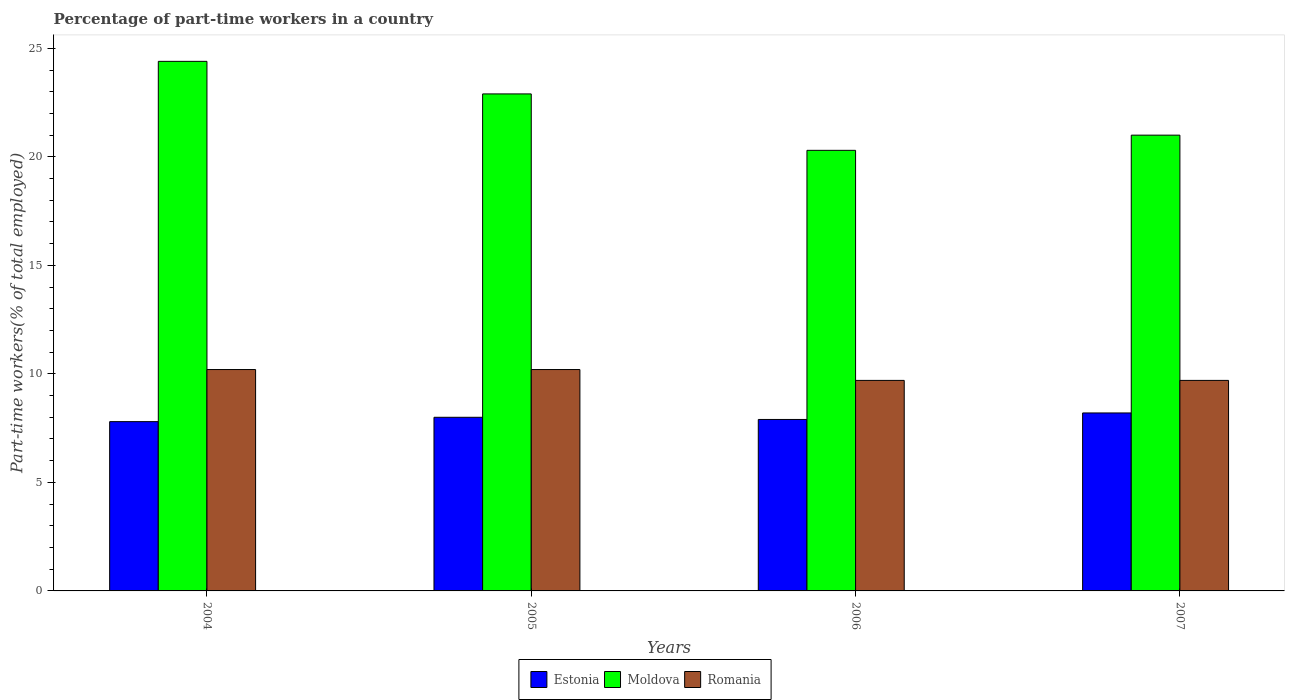How many different coloured bars are there?
Offer a terse response. 3. Are the number of bars on each tick of the X-axis equal?
Ensure brevity in your answer.  Yes. How many bars are there on the 1st tick from the left?
Offer a terse response. 3. How many bars are there on the 4th tick from the right?
Make the answer very short. 3. In how many cases, is the number of bars for a given year not equal to the number of legend labels?
Keep it short and to the point. 0. What is the percentage of part-time workers in Estonia in 2004?
Give a very brief answer. 7.8. Across all years, what is the maximum percentage of part-time workers in Estonia?
Ensure brevity in your answer.  8.2. Across all years, what is the minimum percentage of part-time workers in Moldova?
Give a very brief answer. 20.3. In which year was the percentage of part-time workers in Estonia maximum?
Offer a terse response. 2007. What is the total percentage of part-time workers in Estonia in the graph?
Keep it short and to the point. 31.9. What is the difference between the percentage of part-time workers in Romania in 2004 and that in 2007?
Give a very brief answer. 0.5. What is the difference between the percentage of part-time workers in Romania in 2007 and the percentage of part-time workers in Moldova in 2005?
Keep it short and to the point. -13.2. What is the average percentage of part-time workers in Romania per year?
Offer a terse response. 9.95. In the year 2005, what is the difference between the percentage of part-time workers in Estonia and percentage of part-time workers in Moldova?
Offer a very short reply. -14.9. What is the ratio of the percentage of part-time workers in Estonia in 2005 to that in 2007?
Keep it short and to the point. 0.98. Is the percentage of part-time workers in Romania in 2004 less than that in 2007?
Keep it short and to the point. No. Is the difference between the percentage of part-time workers in Estonia in 2006 and 2007 greater than the difference between the percentage of part-time workers in Moldova in 2006 and 2007?
Provide a short and direct response. Yes. What is the difference between the highest and the second highest percentage of part-time workers in Estonia?
Ensure brevity in your answer.  0.2. What is the difference between the highest and the lowest percentage of part-time workers in Estonia?
Offer a very short reply. 0.4. In how many years, is the percentage of part-time workers in Moldova greater than the average percentage of part-time workers in Moldova taken over all years?
Offer a terse response. 2. Is the sum of the percentage of part-time workers in Estonia in 2006 and 2007 greater than the maximum percentage of part-time workers in Romania across all years?
Ensure brevity in your answer.  Yes. What does the 3rd bar from the left in 2007 represents?
Offer a very short reply. Romania. What does the 2nd bar from the right in 2004 represents?
Offer a very short reply. Moldova. Is it the case that in every year, the sum of the percentage of part-time workers in Estonia and percentage of part-time workers in Moldova is greater than the percentage of part-time workers in Romania?
Give a very brief answer. Yes. What is the difference between two consecutive major ticks on the Y-axis?
Give a very brief answer. 5. Does the graph contain any zero values?
Offer a terse response. No. Does the graph contain grids?
Ensure brevity in your answer.  No. Where does the legend appear in the graph?
Your answer should be compact. Bottom center. What is the title of the graph?
Provide a succinct answer. Percentage of part-time workers in a country. Does "United Arab Emirates" appear as one of the legend labels in the graph?
Your answer should be compact. No. What is the label or title of the X-axis?
Your answer should be very brief. Years. What is the label or title of the Y-axis?
Provide a succinct answer. Part-time workers(% of total employed). What is the Part-time workers(% of total employed) of Estonia in 2004?
Offer a terse response. 7.8. What is the Part-time workers(% of total employed) of Moldova in 2004?
Your answer should be compact. 24.4. What is the Part-time workers(% of total employed) of Romania in 2004?
Offer a very short reply. 10.2. What is the Part-time workers(% of total employed) in Estonia in 2005?
Make the answer very short. 8. What is the Part-time workers(% of total employed) in Moldova in 2005?
Your answer should be very brief. 22.9. What is the Part-time workers(% of total employed) of Romania in 2005?
Ensure brevity in your answer.  10.2. What is the Part-time workers(% of total employed) in Estonia in 2006?
Offer a terse response. 7.9. What is the Part-time workers(% of total employed) of Moldova in 2006?
Offer a very short reply. 20.3. What is the Part-time workers(% of total employed) of Romania in 2006?
Offer a terse response. 9.7. What is the Part-time workers(% of total employed) of Estonia in 2007?
Ensure brevity in your answer.  8.2. What is the Part-time workers(% of total employed) in Moldova in 2007?
Your response must be concise. 21. What is the Part-time workers(% of total employed) of Romania in 2007?
Offer a terse response. 9.7. Across all years, what is the maximum Part-time workers(% of total employed) in Estonia?
Ensure brevity in your answer.  8.2. Across all years, what is the maximum Part-time workers(% of total employed) of Moldova?
Give a very brief answer. 24.4. Across all years, what is the maximum Part-time workers(% of total employed) in Romania?
Keep it short and to the point. 10.2. Across all years, what is the minimum Part-time workers(% of total employed) in Estonia?
Your response must be concise. 7.8. Across all years, what is the minimum Part-time workers(% of total employed) in Moldova?
Your response must be concise. 20.3. Across all years, what is the minimum Part-time workers(% of total employed) in Romania?
Offer a terse response. 9.7. What is the total Part-time workers(% of total employed) of Estonia in the graph?
Provide a short and direct response. 31.9. What is the total Part-time workers(% of total employed) of Moldova in the graph?
Provide a short and direct response. 88.6. What is the total Part-time workers(% of total employed) in Romania in the graph?
Provide a succinct answer. 39.8. What is the difference between the Part-time workers(% of total employed) of Estonia in 2004 and that in 2005?
Ensure brevity in your answer.  -0.2. What is the difference between the Part-time workers(% of total employed) in Moldova in 2004 and that in 2007?
Provide a short and direct response. 3.4. What is the difference between the Part-time workers(% of total employed) of Romania in 2005 and that in 2007?
Make the answer very short. 0.5. What is the difference between the Part-time workers(% of total employed) of Estonia in 2004 and the Part-time workers(% of total employed) of Moldova in 2005?
Offer a terse response. -15.1. What is the difference between the Part-time workers(% of total employed) of Estonia in 2004 and the Part-time workers(% of total employed) of Romania in 2006?
Make the answer very short. -1.9. What is the difference between the Part-time workers(% of total employed) in Estonia in 2004 and the Part-time workers(% of total employed) in Romania in 2007?
Provide a succinct answer. -1.9. What is the difference between the Part-time workers(% of total employed) of Estonia in 2005 and the Part-time workers(% of total employed) of Moldova in 2006?
Provide a succinct answer. -12.3. What is the difference between the Part-time workers(% of total employed) of Estonia in 2005 and the Part-time workers(% of total employed) of Romania in 2006?
Offer a very short reply. -1.7. What is the difference between the Part-time workers(% of total employed) of Estonia in 2005 and the Part-time workers(% of total employed) of Moldova in 2007?
Your answer should be compact. -13. What is the difference between the Part-time workers(% of total employed) of Moldova in 2005 and the Part-time workers(% of total employed) of Romania in 2007?
Make the answer very short. 13.2. What is the difference between the Part-time workers(% of total employed) of Estonia in 2006 and the Part-time workers(% of total employed) of Moldova in 2007?
Offer a terse response. -13.1. What is the difference between the Part-time workers(% of total employed) in Estonia in 2006 and the Part-time workers(% of total employed) in Romania in 2007?
Keep it short and to the point. -1.8. What is the difference between the Part-time workers(% of total employed) in Moldova in 2006 and the Part-time workers(% of total employed) in Romania in 2007?
Offer a very short reply. 10.6. What is the average Part-time workers(% of total employed) of Estonia per year?
Your response must be concise. 7.97. What is the average Part-time workers(% of total employed) in Moldova per year?
Your answer should be compact. 22.15. What is the average Part-time workers(% of total employed) of Romania per year?
Provide a succinct answer. 9.95. In the year 2004, what is the difference between the Part-time workers(% of total employed) in Estonia and Part-time workers(% of total employed) in Moldova?
Offer a very short reply. -16.6. In the year 2004, what is the difference between the Part-time workers(% of total employed) in Moldova and Part-time workers(% of total employed) in Romania?
Your answer should be very brief. 14.2. In the year 2005, what is the difference between the Part-time workers(% of total employed) in Estonia and Part-time workers(% of total employed) in Moldova?
Your response must be concise. -14.9. In the year 2006, what is the difference between the Part-time workers(% of total employed) of Estonia and Part-time workers(% of total employed) of Moldova?
Your answer should be compact. -12.4. In the year 2006, what is the difference between the Part-time workers(% of total employed) in Estonia and Part-time workers(% of total employed) in Romania?
Your answer should be very brief. -1.8. In the year 2006, what is the difference between the Part-time workers(% of total employed) of Moldova and Part-time workers(% of total employed) of Romania?
Make the answer very short. 10.6. In the year 2007, what is the difference between the Part-time workers(% of total employed) in Estonia and Part-time workers(% of total employed) in Romania?
Your response must be concise. -1.5. In the year 2007, what is the difference between the Part-time workers(% of total employed) in Moldova and Part-time workers(% of total employed) in Romania?
Offer a terse response. 11.3. What is the ratio of the Part-time workers(% of total employed) of Moldova in 2004 to that in 2005?
Make the answer very short. 1.07. What is the ratio of the Part-time workers(% of total employed) in Romania in 2004 to that in 2005?
Give a very brief answer. 1. What is the ratio of the Part-time workers(% of total employed) of Estonia in 2004 to that in 2006?
Make the answer very short. 0.99. What is the ratio of the Part-time workers(% of total employed) of Moldova in 2004 to that in 2006?
Keep it short and to the point. 1.2. What is the ratio of the Part-time workers(% of total employed) in Romania in 2004 to that in 2006?
Give a very brief answer. 1.05. What is the ratio of the Part-time workers(% of total employed) of Estonia in 2004 to that in 2007?
Your answer should be very brief. 0.95. What is the ratio of the Part-time workers(% of total employed) of Moldova in 2004 to that in 2007?
Your answer should be very brief. 1.16. What is the ratio of the Part-time workers(% of total employed) in Romania in 2004 to that in 2007?
Your answer should be very brief. 1.05. What is the ratio of the Part-time workers(% of total employed) of Estonia in 2005 to that in 2006?
Offer a terse response. 1.01. What is the ratio of the Part-time workers(% of total employed) in Moldova in 2005 to that in 2006?
Offer a very short reply. 1.13. What is the ratio of the Part-time workers(% of total employed) of Romania in 2005 to that in 2006?
Offer a terse response. 1.05. What is the ratio of the Part-time workers(% of total employed) of Estonia in 2005 to that in 2007?
Provide a short and direct response. 0.98. What is the ratio of the Part-time workers(% of total employed) of Moldova in 2005 to that in 2007?
Provide a succinct answer. 1.09. What is the ratio of the Part-time workers(% of total employed) of Romania in 2005 to that in 2007?
Offer a very short reply. 1.05. What is the ratio of the Part-time workers(% of total employed) in Estonia in 2006 to that in 2007?
Provide a short and direct response. 0.96. What is the ratio of the Part-time workers(% of total employed) in Moldova in 2006 to that in 2007?
Your answer should be compact. 0.97. What is the difference between the highest and the second highest Part-time workers(% of total employed) in Estonia?
Offer a terse response. 0.2. What is the difference between the highest and the second highest Part-time workers(% of total employed) of Romania?
Your answer should be compact. 0. What is the difference between the highest and the lowest Part-time workers(% of total employed) of Estonia?
Provide a succinct answer. 0.4. What is the difference between the highest and the lowest Part-time workers(% of total employed) of Moldova?
Your answer should be very brief. 4.1. What is the difference between the highest and the lowest Part-time workers(% of total employed) of Romania?
Offer a very short reply. 0.5. 